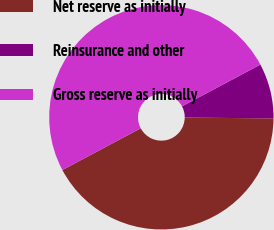Convert chart. <chart><loc_0><loc_0><loc_500><loc_500><pie_chart><fcel>Net reserve as initially<fcel>Reinsurance and other<fcel>Gross reserve as initially<nl><fcel>42.05%<fcel>7.95%<fcel>50.0%<nl></chart> 